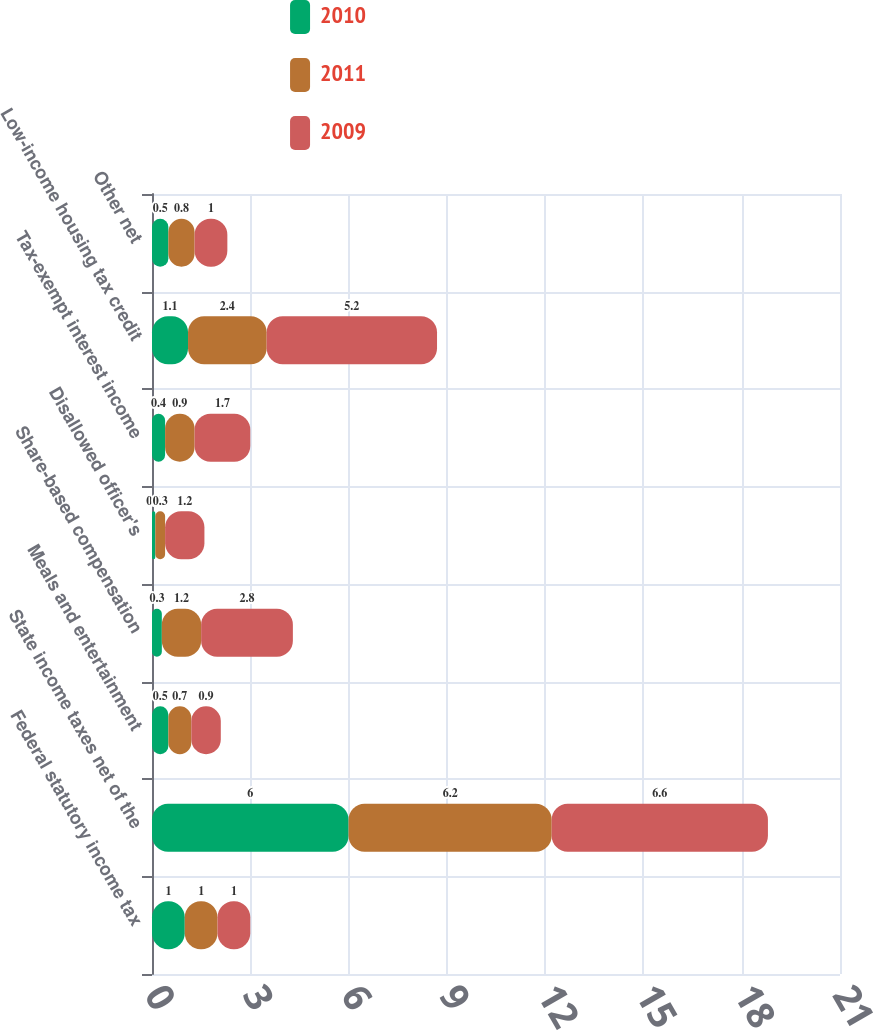Convert chart. <chart><loc_0><loc_0><loc_500><loc_500><stacked_bar_chart><ecel><fcel>Federal statutory income tax<fcel>State income taxes net of the<fcel>Meals and entertainment<fcel>Share-based compensation<fcel>Disallowed officer's<fcel>Tax-exempt interest income<fcel>Low-income housing tax credit<fcel>Other net<nl><fcel>2010<fcel>1<fcel>6<fcel>0.5<fcel>0.3<fcel>0.1<fcel>0.4<fcel>1.1<fcel>0.5<nl><fcel>2011<fcel>1<fcel>6.2<fcel>0.7<fcel>1.2<fcel>0.3<fcel>0.9<fcel>2.4<fcel>0.8<nl><fcel>2009<fcel>1<fcel>6.6<fcel>0.9<fcel>2.8<fcel>1.2<fcel>1.7<fcel>5.2<fcel>1<nl></chart> 